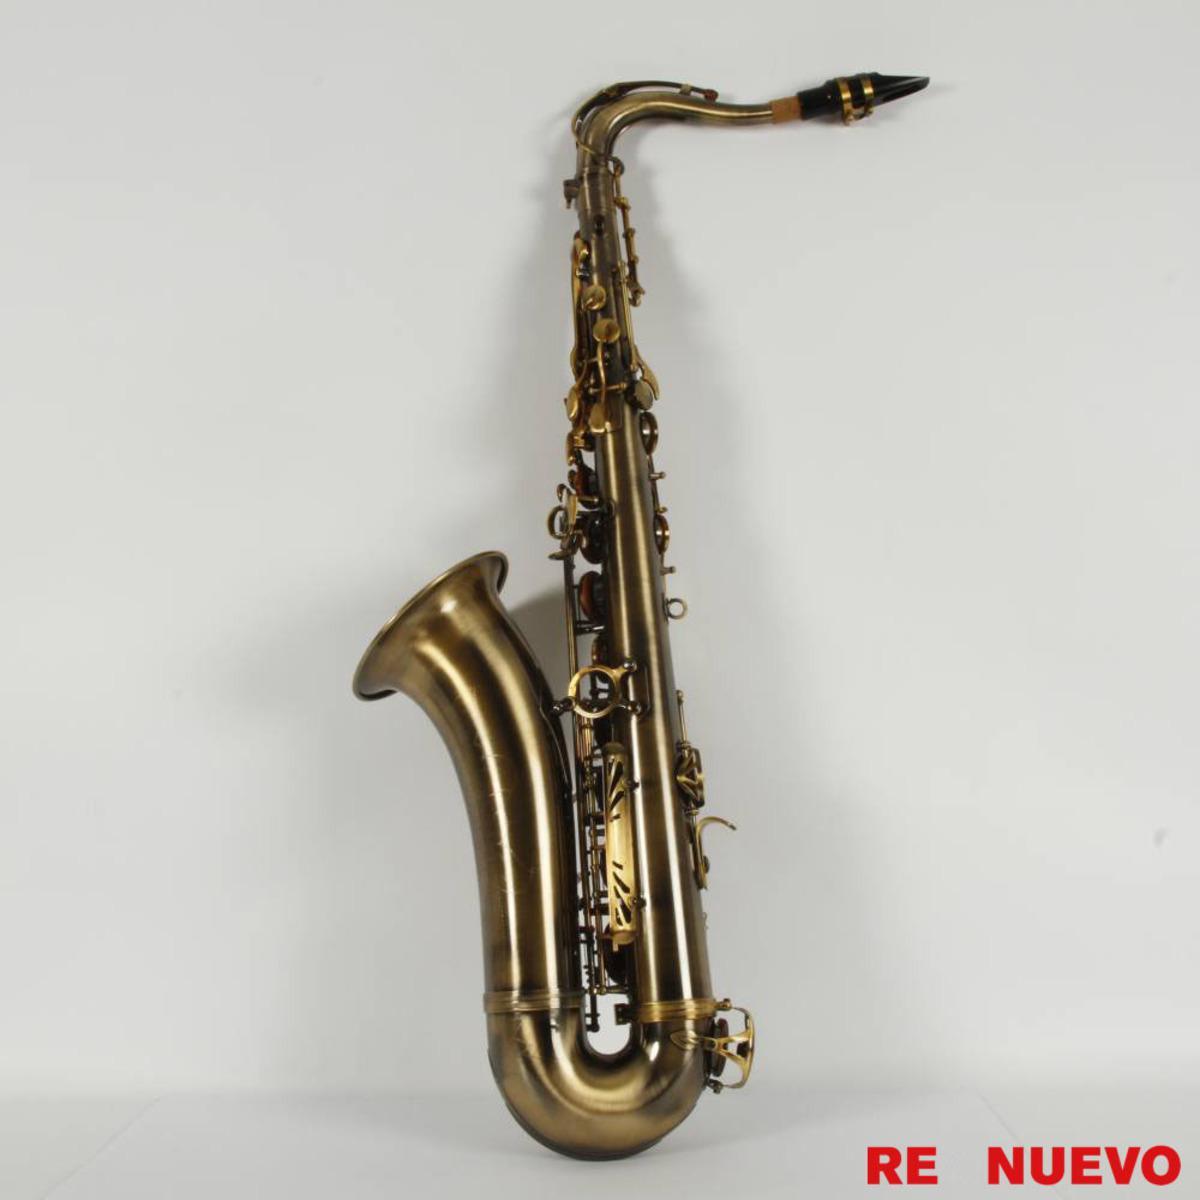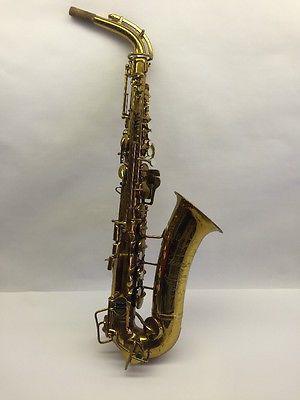The first image is the image on the left, the second image is the image on the right. Considering the images on both sides, is "The saxophone in one of the images is against a solid white background." valid? Answer yes or no. No. 